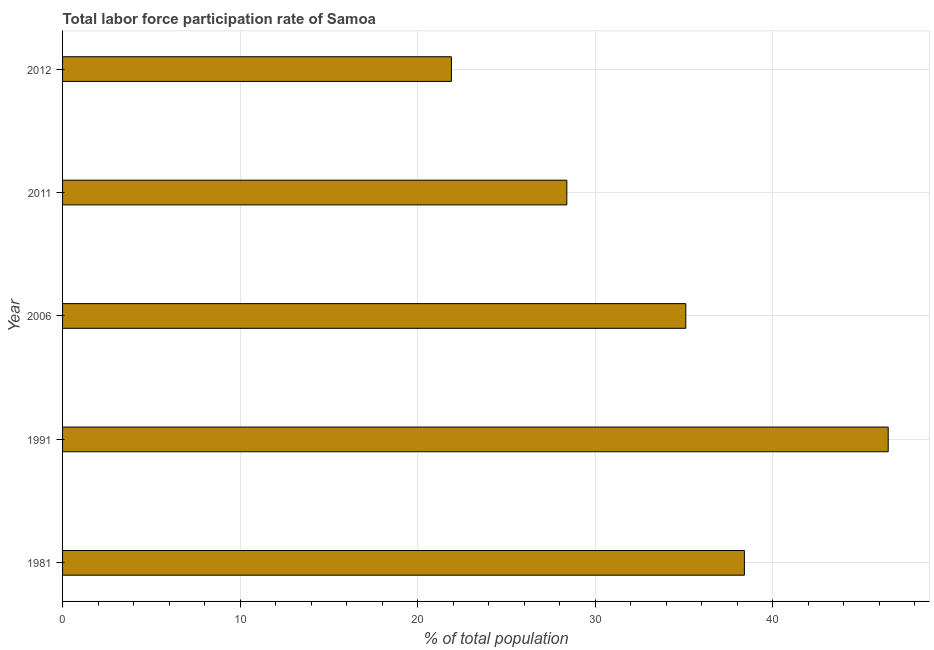Does the graph contain grids?
Your answer should be compact. Yes. What is the title of the graph?
Keep it short and to the point. Total labor force participation rate of Samoa. What is the label or title of the X-axis?
Provide a short and direct response. % of total population. What is the total labor force participation rate in 1991?
Offer a terse response. 46.5. Across all years, what is the maximum total labor force participation rate?
Make the answer very short. 46.5. Across all years, what is the minimum total labor force participation rate?
Provide a short and direct response. 21.9. What is the sum of the total labor force participation rate?
Ensure brevity in your answer.  170.3. What is the average total labor force participation rate per year?
Offer a terse response. 34.06. What is the median total labor force participation rate?
Offer a very short reply. 35.1. Do a majority of the years between 1991 and 2011 (inclusive) have total labor force participation rate greater than 26 %?
Ensure brevity in your answer.  Yes. What is the ratio of the total labor force participation rate in 1981 to that in 2012?
Your response must be concise. 1.75. Is the total labor force participation rate in 1981 less than that in 1991?
Give a very brief answer. Yes. Is the difference between the total labor force participation rate in 2006 and 2011 greater than the difference between any two years?
Your response must be concise. No. What is the difference between the highest and the second highest total labor force participation rate?
Provide a short and direct response. 8.1. What is the difference between the highest and the lowest total labor force participation rate?
Offer a very short reply. 24.6. In how many years, is the total labor force participation rate greater than the average total labor force participation rate taken over all years?
Make the answer very short. 3. How many years are there in the graph?
Make the answer very short. 5. What is the % of total population of 1981?
Offer a terse response. 38.4. What is the % of total population in 1991?
Provide a short and direct response. 46.5. What is the % of total population in 2006?
Make the answer very short. 35.1. What is the % of total population in 2011?
Keep it short and to the point. 28.4. What is the % of total population in 2012?
Ensure brevity in your answer.  21.9. What is the difference between the % of total population in 1981 and 1991?
Ensure brevity in your answer.  -8.1. What is the difference between the % of total population in 1981 and 2006?
Ensure brevity in your answer.  3.3. What is the difference between the % of total population in 1981 and 2011?
Make the answer very short. 10. What is the difference between the % of total population in 1991 and 2011?
Make the answer very short. 18.1. What is the difference between the % of total population in 1991 and 2012?
Keep it short and to the point. 24.6. What is the difference between the % of total population in 2006 and 2011?
Give a very brief answer. 6.7. What is the difference between the % of total population in 2006 and 2012?
Your response must be concise. 13.2. What is the difference between the % of total population in 2011 and 2012?
Your answer should be compact. 6.5. What is the ratio of the % of total population in 1981 to that in 1991?
Ensure brevity in your answer.  0.83. What is the ratio of the % of total population in 1981 to that in 2006?
Keep it short and to the point. 1.09. What is the ratio of the % of total population in 1981 to that in 2011?
Ensure brevity in your answer.  1.35. What is the ratio of the % of total population in 1981 to that in 2012?
Give a very brief answer. 1.75. What is the ratio of the % of total population in 1991 to that in 2006?
Your answer should be very brief. 1.32. What is the ratio of the % of total population in 1991 to that in 2011?
Make the answer very short. 1.64. What is the ratio of the % of total population in 1991 to that in 2012?
Offer a very short reply. 2.12. What is the ratio of the % of total population in 2006 to that in 2011?
Offer a very short reply. 1.24. What is the ratio of the % of total population in 2006 to that in 2012?
Your answer should be very brief. 1.6. What is the ratio of the % of total population in 2011 to that in 2012?
Your response must be concise. 1.3. 